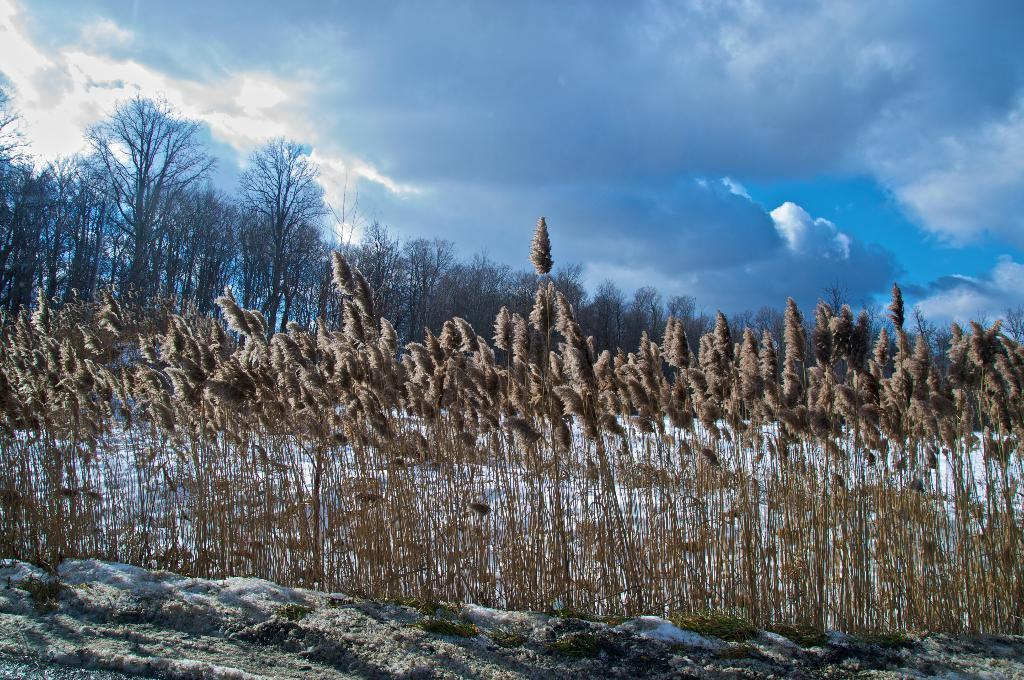What type of trees are in the image? There are dry trees in the image. What is the weather like in the image? There is snow visible in the image, indicating a cold or wintry environment. What color are the plants in the image? The plants in the image have a brown color. What colors can be seen in the sky in the image? The sky is blue and white in color. How much payment is required to ride the railway in the image? There is no railway present in the image, so the question of payment is not applicable. 